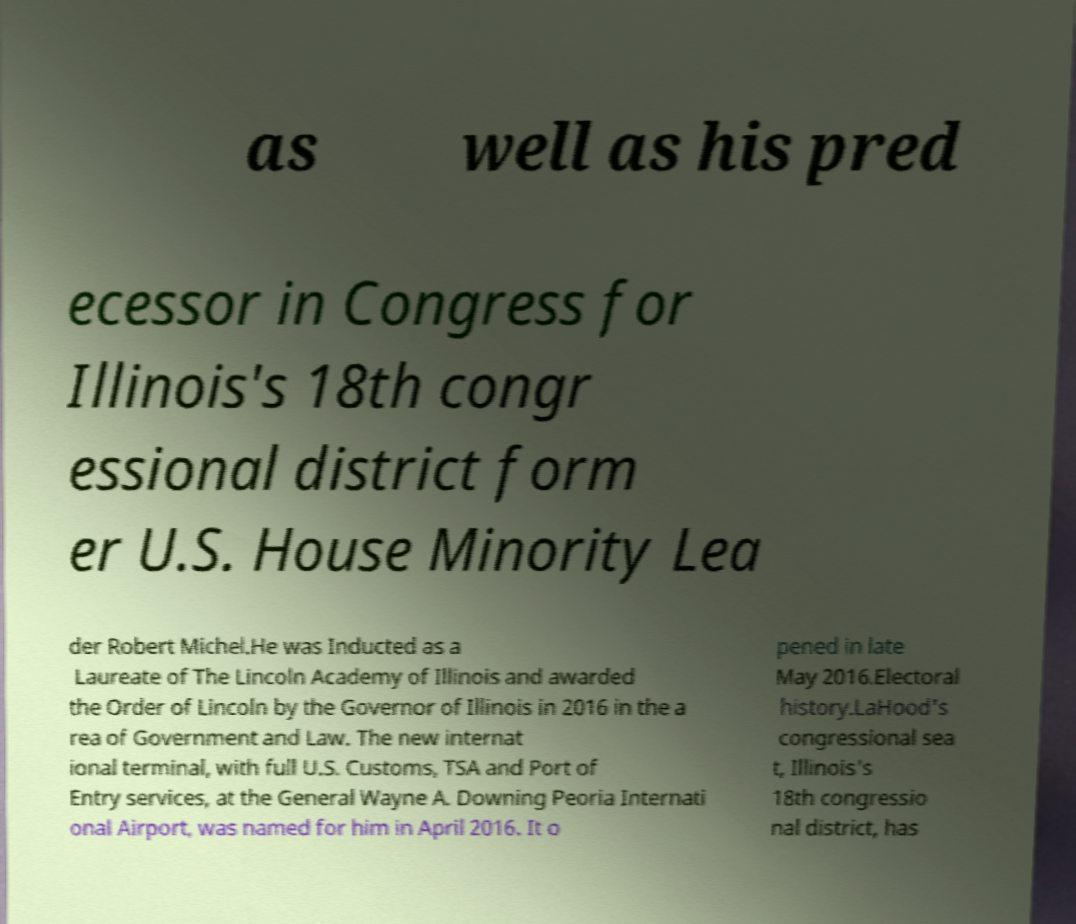Please read and relay the text visible in this image. What does it say? as well as his pred ecessor in Congress for Illinois's 18th congr essional district form er U.S. House Minority Lea der Robert Michel.He was Inducted as a Laureate of The Lincoln Academy of Illinois and awarded the Order of Lincoln by the Governor of Illinois in 2016 in the a rea of Government and Law. The new internat ional terminal, with full U.S. Customs, TSA and Port of Entry services, at the General Wayne A. Downing Peoria Internati onal Airport, was named for him in April 2016. It o pened in late May 2016.Electoral history.LaHood's congressional sea t, Illinois's 18th congressio nal district, has 